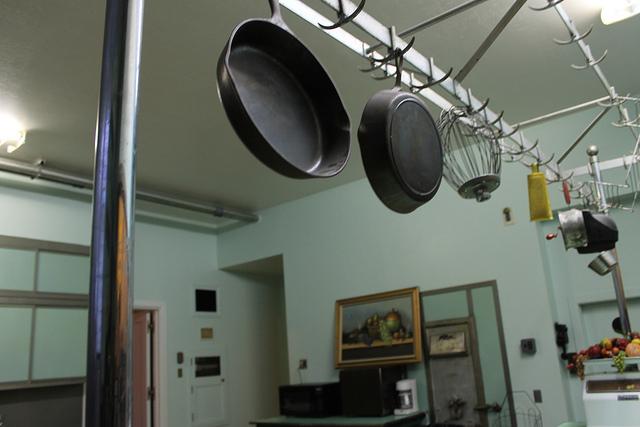What room is this?
Concise answer only. Kitchen. What is the subject of the painting on the far wall?
Keep it brief. Fruit. What material are the frying pans made of?
Give a very brief answer. Cast iron. 